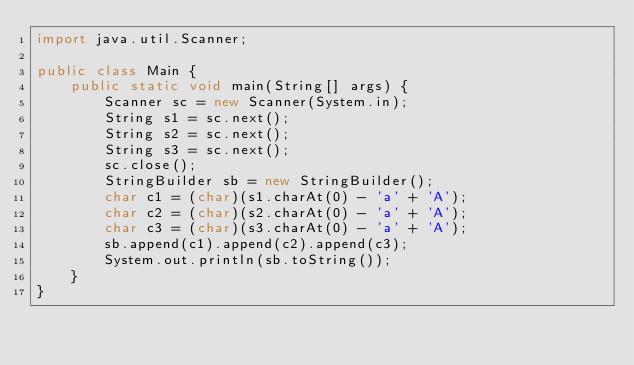Convert code to text. <code><loc_0><loc_0><loc_500><loc_500><_Java_>import java.util.Scanner;

public class Main {
	public static void main(String[] args) {
		Scanner sc = new Scanner(System.in);
		String s1 = sc.next();
		String s2 = sc.next();
		String s3 = sc.next();
		sc.close();
		StringBuilder sb = new StringBuilder();
		char c1 = (char)(s1.charAt(0) - 'a' + 'A');
		char c2 = (char)(s2.charAt(0) - 'a' + 'A');
		char c3 = (char)(s3.charAt(0) - 'a' + 'A');
		sb.append(c1).append(c2).append(c3);
		System.out.println(sb.toString());
	}
}</code> 